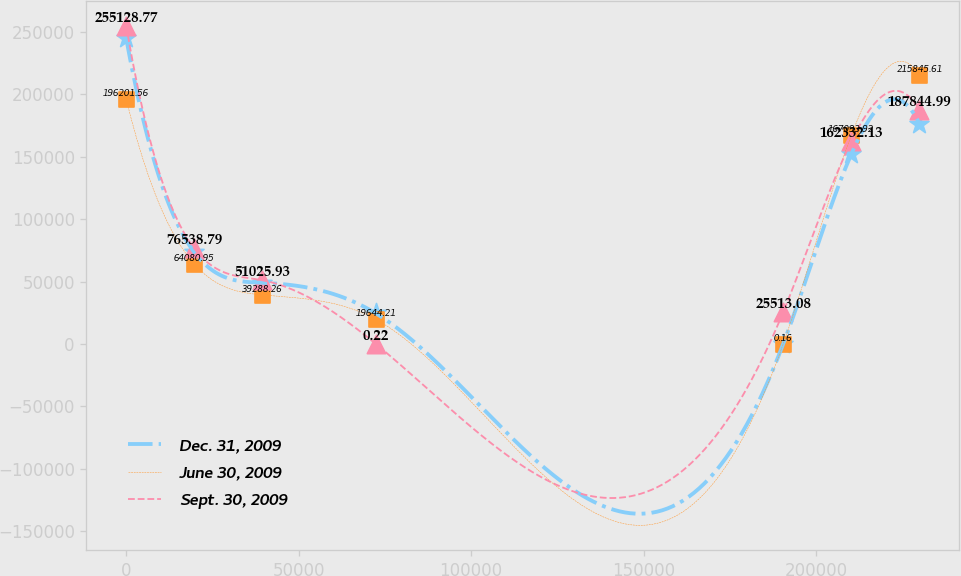Convert chart to OTSL. <chart><loc_0><loc_0><loc_500><loc_500><line_chart><ecel><fcel>Dec. 31, 2009<fcel>June 30, 2009<fcel>Sept. 30, 2009<nl><fcel>22.29<fcel>245084<fcel>196202<fcel>255129<nl><fcel>19759<fcel>73525.4<fcel>64080.9<fcel>76538.8<nl><fcel>39495.8<fcel>49017<fcel>39288.3<fcel>51025.9<nl><fcel>72394.4<fcel>24508.6<fcel>19644.2<fcel>0.22<nl><fcel>190499<fcel>0.21<fcel>0.16<fcel>25513.1<nl><fcel>210236<fcel>152099<fcel>167094<fcel>162332<nl><fcel>229972<fcel>176608<fcel>215846<fcel>187845<nl></chart> 